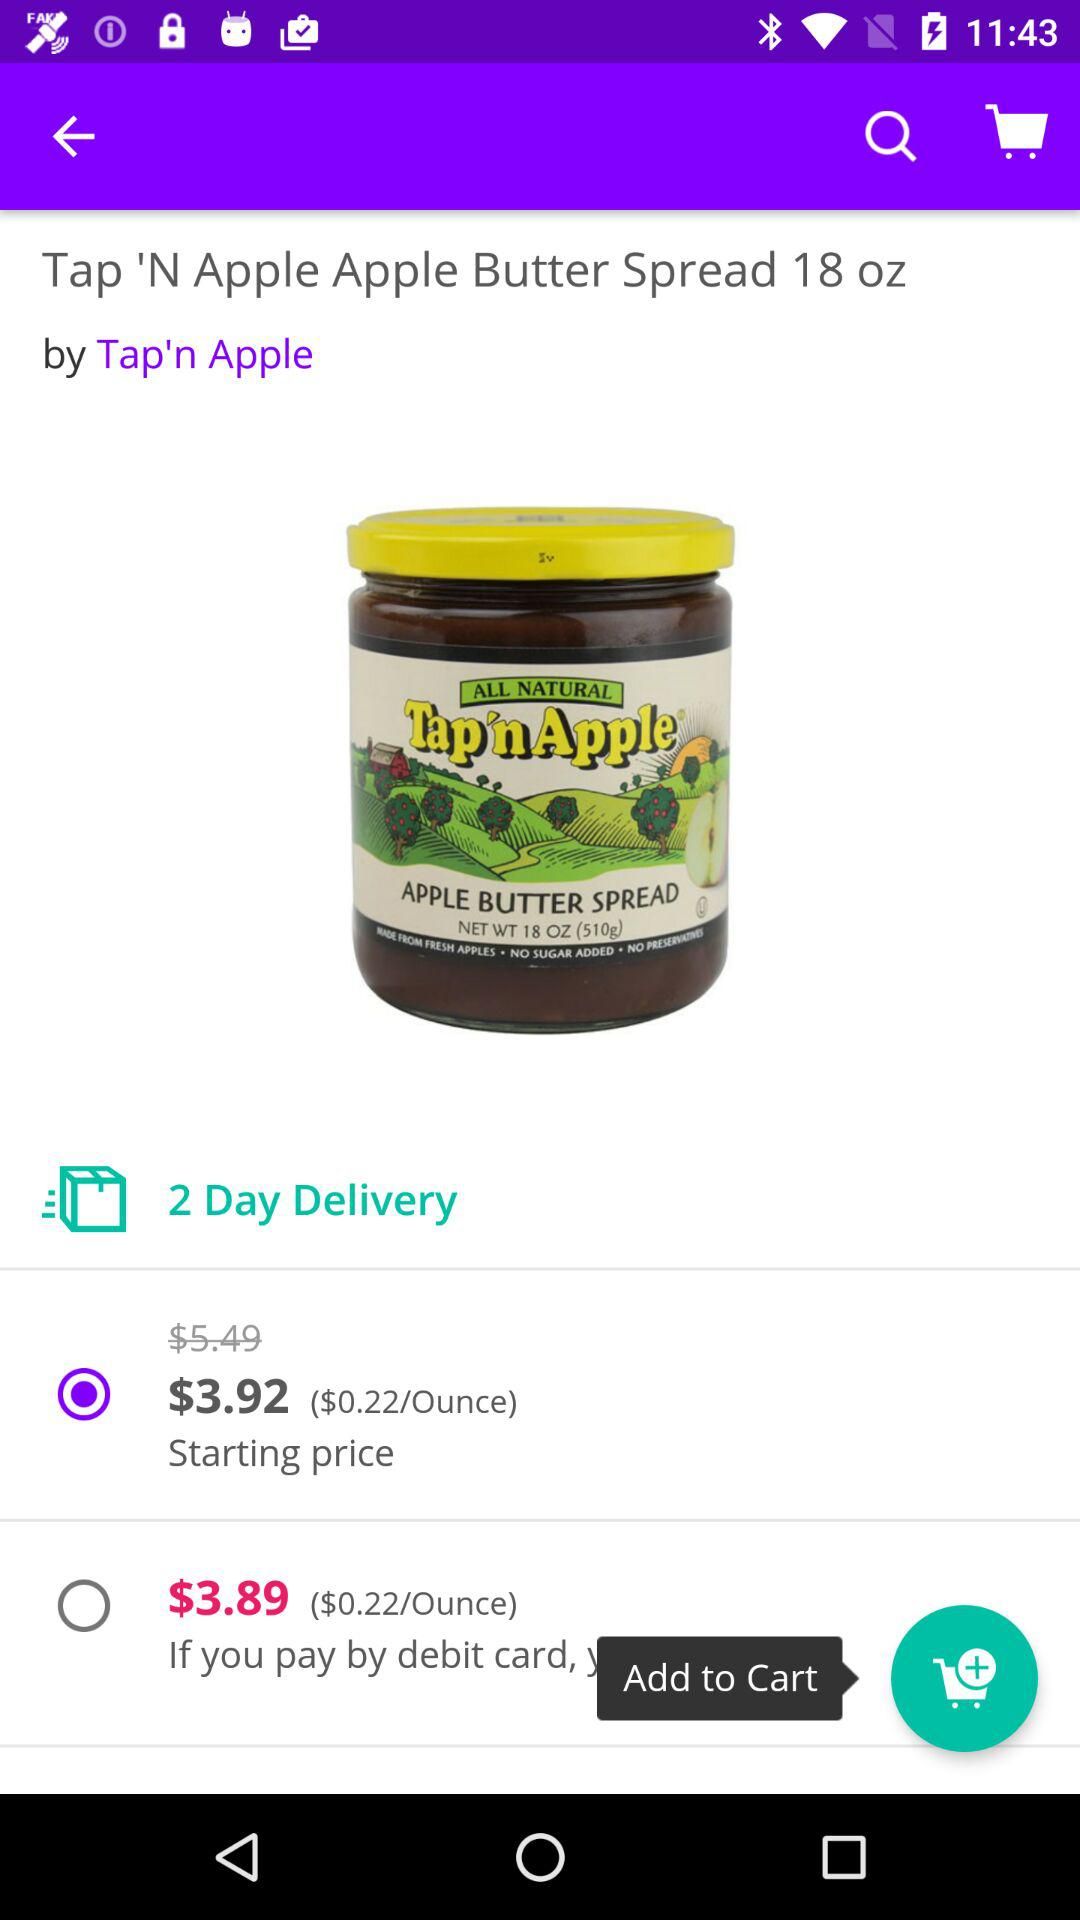What is the company name of the "Apple Butter Spread"? The company name of the "Apple Butter Spread" is "Tap'n Apple". 